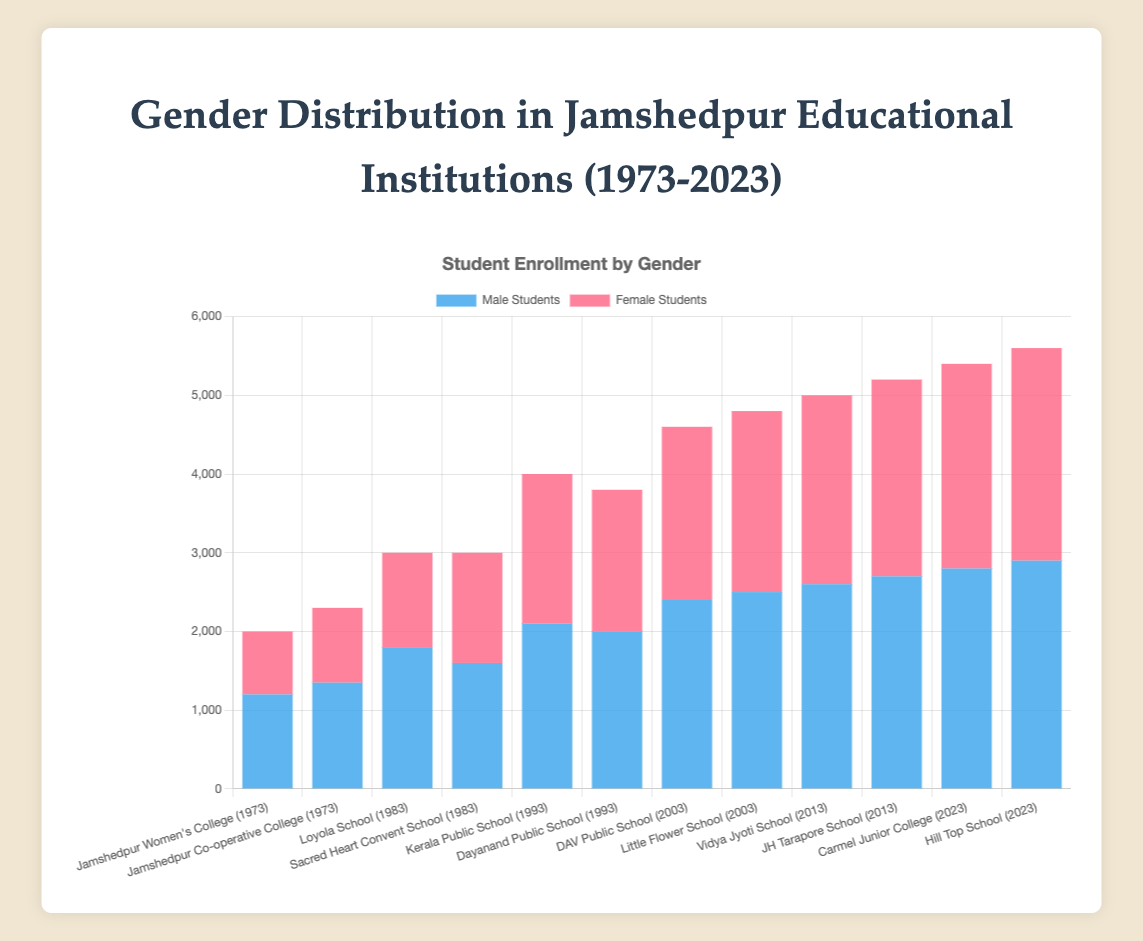Which institution had the highest number of male students in 2023? Looking at the year 2023, compare the heights of the bars for "Carmel Junior College" and "Hill Top School" under the 'Male Students' category. Hill Top School has the higher bar.
Answer: Hill Top School By how much did the male student enrollment at Jamshedpur Co-operative College increase from 1973 to 2023? The enrollment for male students at Jamshedpur Co-operative College in 1973 was 1350. Notice that there is no data provided for this college in 2023, so this question cannot be answered with the available figure.
Answer: N/A Which institution in 1983 had a greater number of female students, Loyola School or Sacred Heart Convent School? In the year 1983, compare the heights of the bars for 'Loyola School' and 'Sacred Heart Convent School' under the 'Female Students' category. Sacred Heart Convent School has the taller bar.
Answer: Sacred Heart Convent School What is the total number of students enrolled (both male and female) at Kerala Public School in 1993? Add the male and female student enrollments at Kerala Public School in 1993: 2100 (male) + 1900 (female) = 4000.
Answer: 4000 Is the male student enrollment trend increasing over the years for all institutions? Observing the heights of the bars over time (from 1973 to 2023) for male students, note if they generally increase at each institution. All institutions show an increase.
Answer: Yes In 2003, which institution had nearly equal numbers of male and female students? Compare the height of the bars for male and female students in 2003. Both 'DAV Public School' and 'Little Flower School' have close heights but 'DAV Public School' is nearly equal.
Answer: DAV Public School Between 1973 and 2023, which year showed a significant leap in female student enrollment at any institution? Compare the heights of the bars labeled 'Female Students' across different years. Identify the year showing a large increase, particularly in recent years. The year 2003 shows a significant leap, particularly in 'Little Flower School'.
Answer: 2003 How many more female students were there in Hill Top School compared to Carmel Junior College in 2023? Compare the heights of the bars under the 'Female Students' category for Hill Top School and Carmel Junior College in 2023: 2700 (Hill Top School) - 2600 (Carmel Junior College) = 100.
Answer: 100 Which institution saw a higher total enrollment, male plus female, in 2013: Vidya Jyoti School or JH Tarapore School? Add both male and female students for each school in 2013 and compare: 
Vidya Jyoti School: 2600 (male) + 2400 (female) = 5000;
JH Tarapore School: 2700 (male) + 2500 (female) = 5200.
JH Tarapore School has a higher total.
Answer: JH Tarapore School 